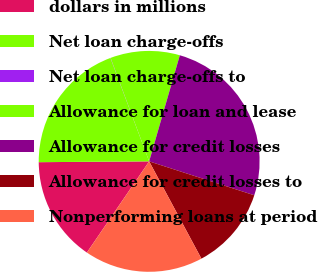Convert chart. <chart><loc_0><loc_0><loc_500><loc_500><pie_chart><fcel>dollars in millions<fcel>Net loan charge-offs<fcel>Net loan charge-offs to<fcel>Allowance for loan and lease<fcel>Allowance for credit losses<fcel>Allowance for credit losses to<fcel>Nonperforming loans at period<nl><fcel>15.35%<fcel>19.41%<fcel>0.03%<fcel>10.16%<fcel>25.49%<fcel>12.19%<fcel>17.38%<nl></chart> 